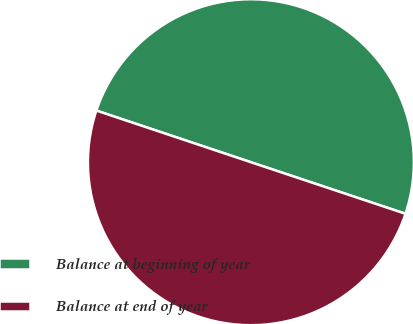<chart> <loc_0><loc_0><loc_500><loc_500><pie_chart><fcel>Balance at beginning of year<fcel>Balance at end of year<nl><fcel>49.99%<fcel>50.01%<nl></chart> 